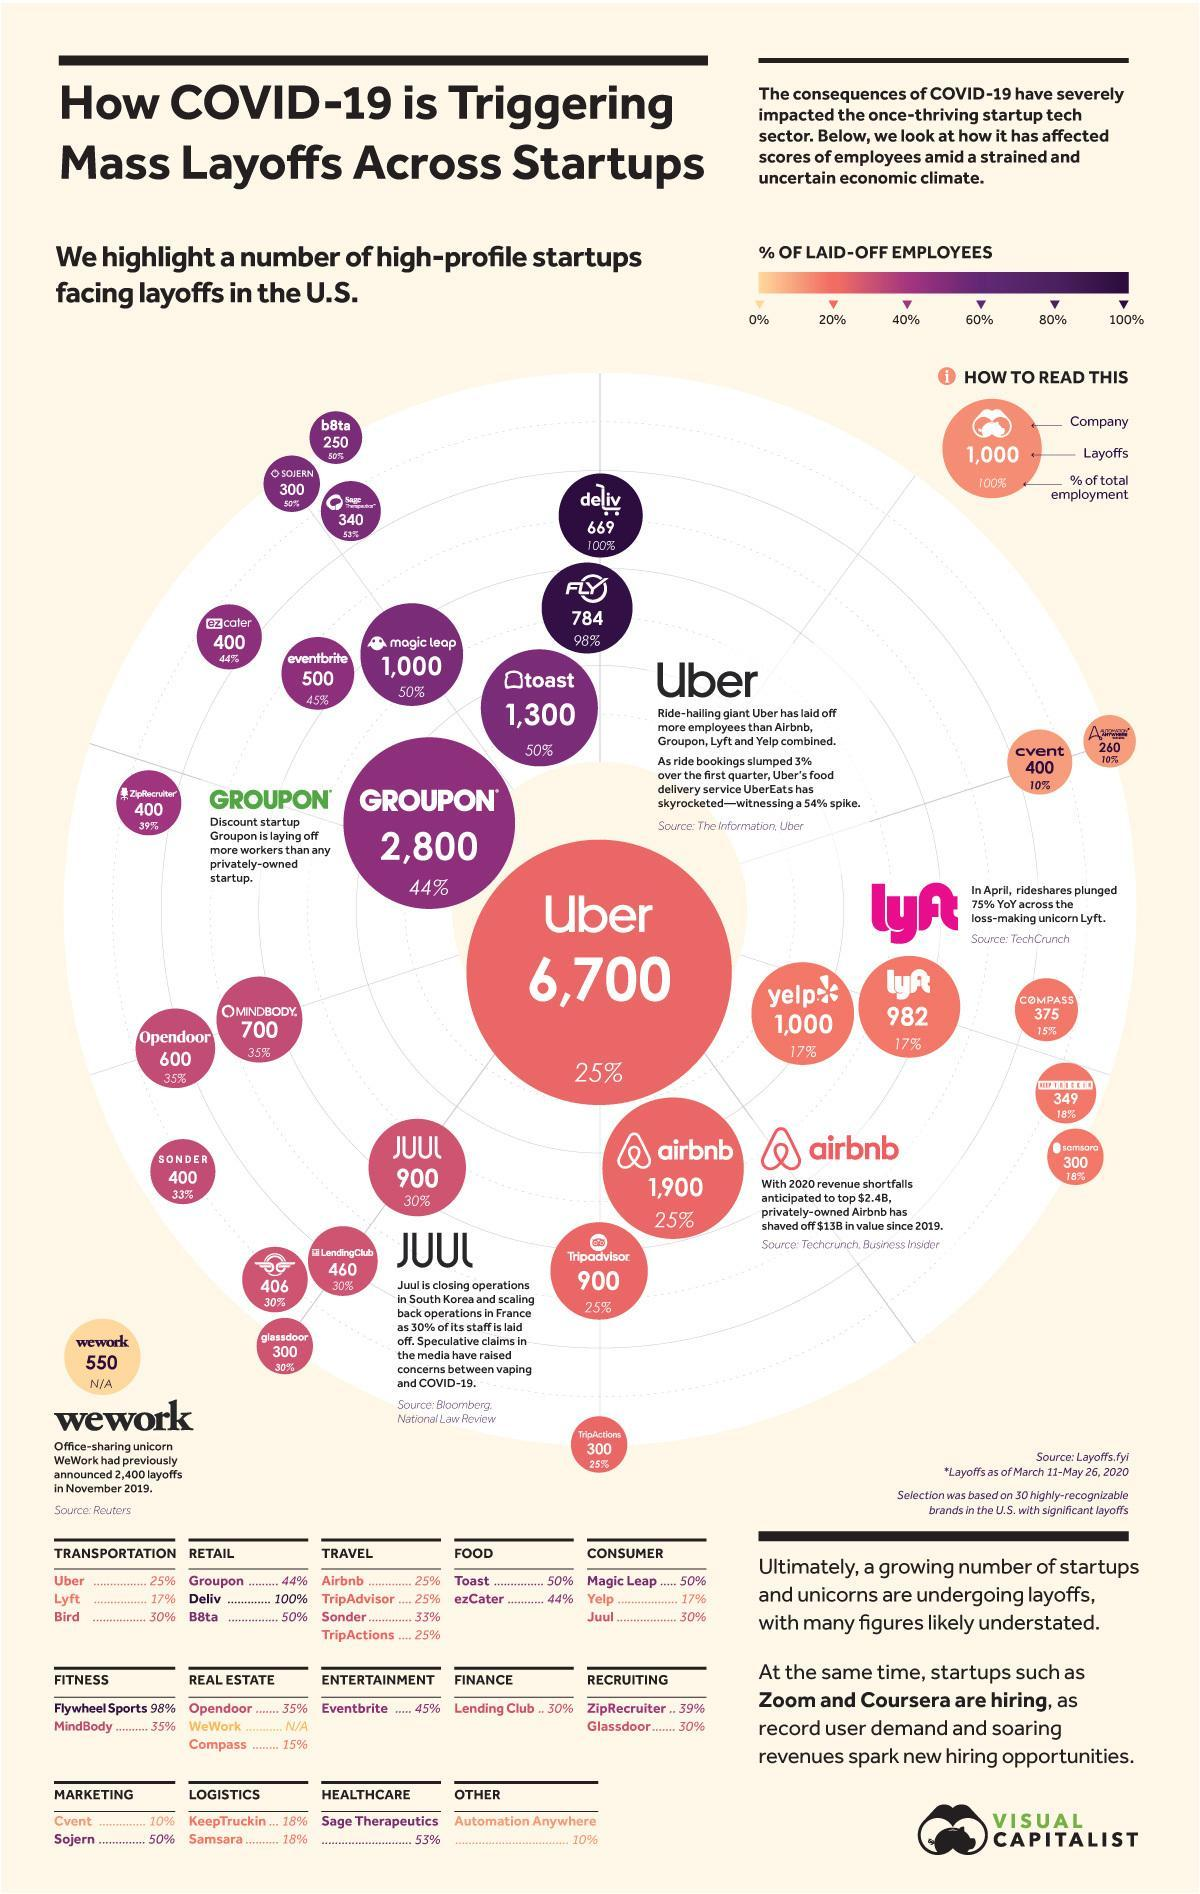What percentage of employees are fired by toast?
Answer the question with a short phrase. 50% How many employees Groupon fired? 2,800 Which company fired the highest number of employees? Uber What percentage of employees are fired by magic leap? 50% How many employees Uber fired? 6,700 What percentage of employees are not fired by Yelp? 83% 